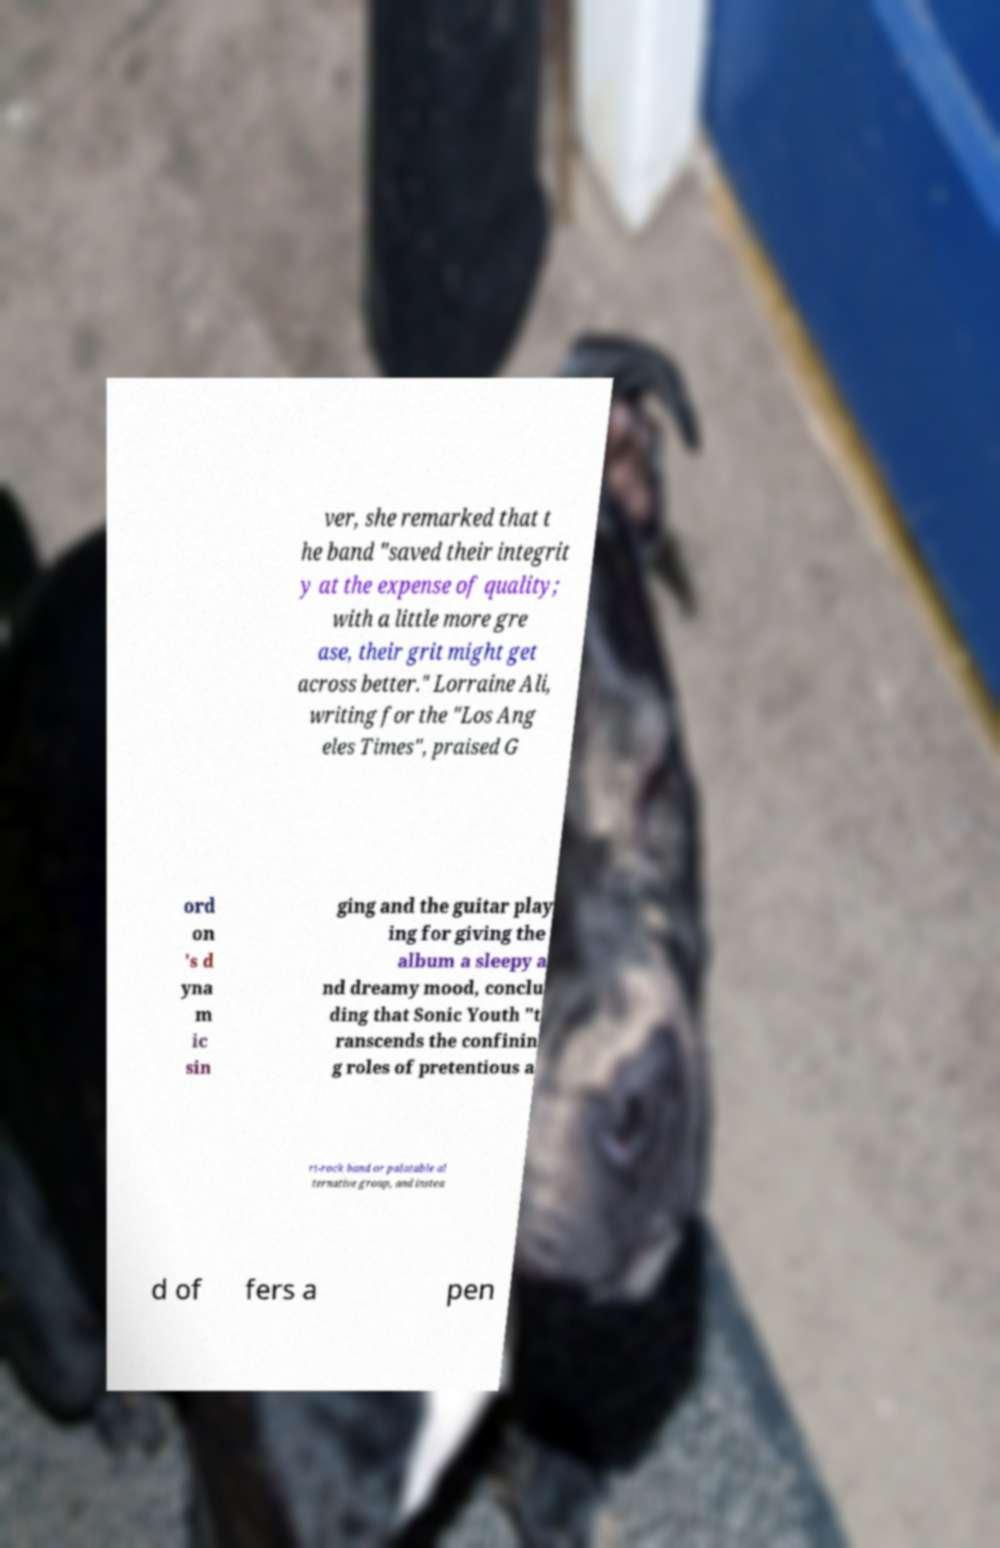Please identify and transcribe the text found in this image. ver, she remarked that t he band "saved their integrit y at the expense of quality; with a little more gre ase, their grit might get across better." Lorraine Ali, writing for the "Los Ang eles Times", praised G ord on 's d yna m ic sin ging and the guitar play ing for giving the album a sleepy a nd dreamy mood, conclu ding that Sonic Youth "t ranscends the confinin g roles of pretentious a rt-rock band or palatable al ternative group, and instea d of fers a pen 